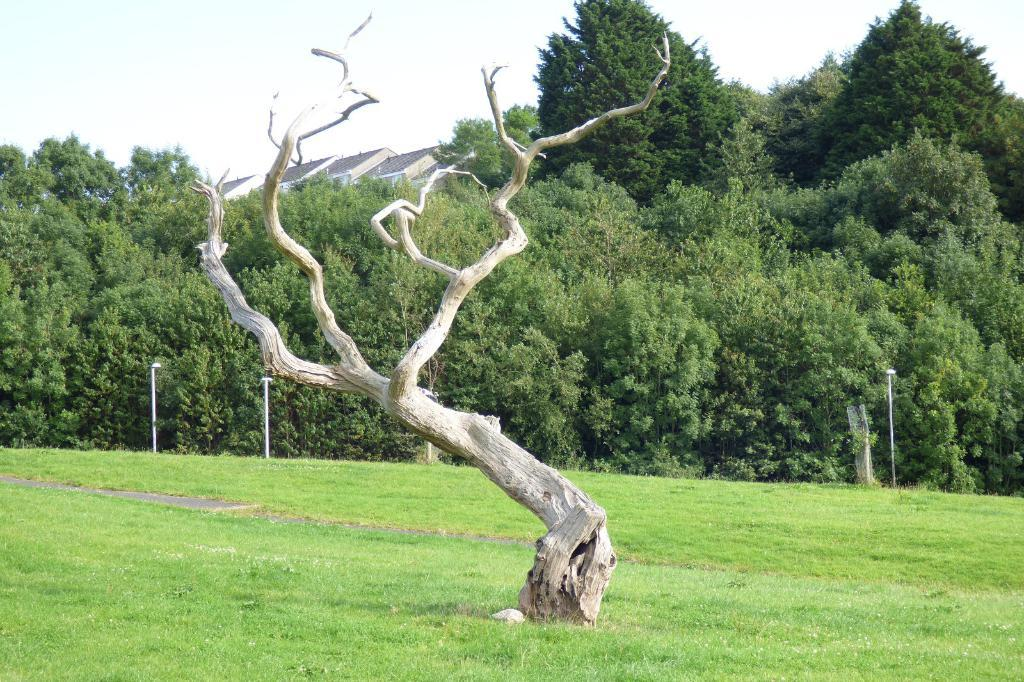What type of vegetation is present in the image? There is grass in the image. What structures can be seen in the image? There are poles and a roof visible in the image. What type of natural elements are present in the image? There are trees in the image. What is visible in the background of the image? The sky is visible in the background of the image. Can you read the question on the receipt in the image? There is no receipt present in the image, so it is not possible to read any questions on it. 